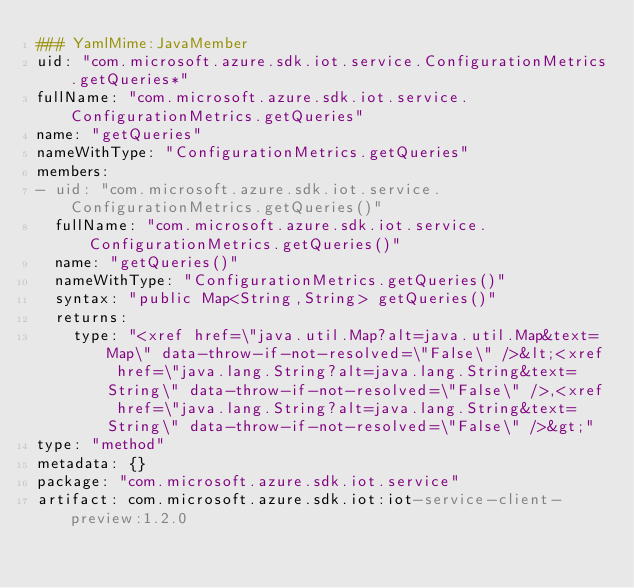<code> <loc_0><loc_0><loc_500><loc_500><_YAML_>### YamlMime:JavaMember
uid: "com.microsoft.azure.sdk.iot.service.ConfigurationMetrics.getQueries*"
fullName: "com.microsoft.azure.sdk.iot.service.ConfigurationMetrics.getQueries"
name: "getQueries"
nameWithType: "ConfigurationMetrics.getQueries"
members:
- uid: "com.microsoft.azure.sdk.iot.service.ConfigurationMetrics.getQueries()"
  fullName: "com.microsoft.azure.sdk.iot.service.ConfigurationMetrics.getQueries()"
  name: "getQueries()"
  nameWithType: "ConfigurationMetrics.getQueries()"
  syntax: "public Map<String,String> getQueries()"
  returns:
    type: "<xref href=\"java.util.Map?alt=java.util.Map&text=Map\" data-throw-if-not-resolved=\"False\" />&lt;<xref href=\"java.lang.String?alt=java.lang.String&text=String\" data-throw-if-not-resolved=\"False\" />,<xref href=\"java.lang.String?alt=java.lang.String&text=String\" data-throw-if-not-resolved=\"False\" />&gt;"
type: "method"
metadata: {}
package: "com.microsoft.azure.sdk.iot.service"
artifact: com.microsoft.azure.sdk.iot:iot-service-client-preview:1.2.0
</code> 